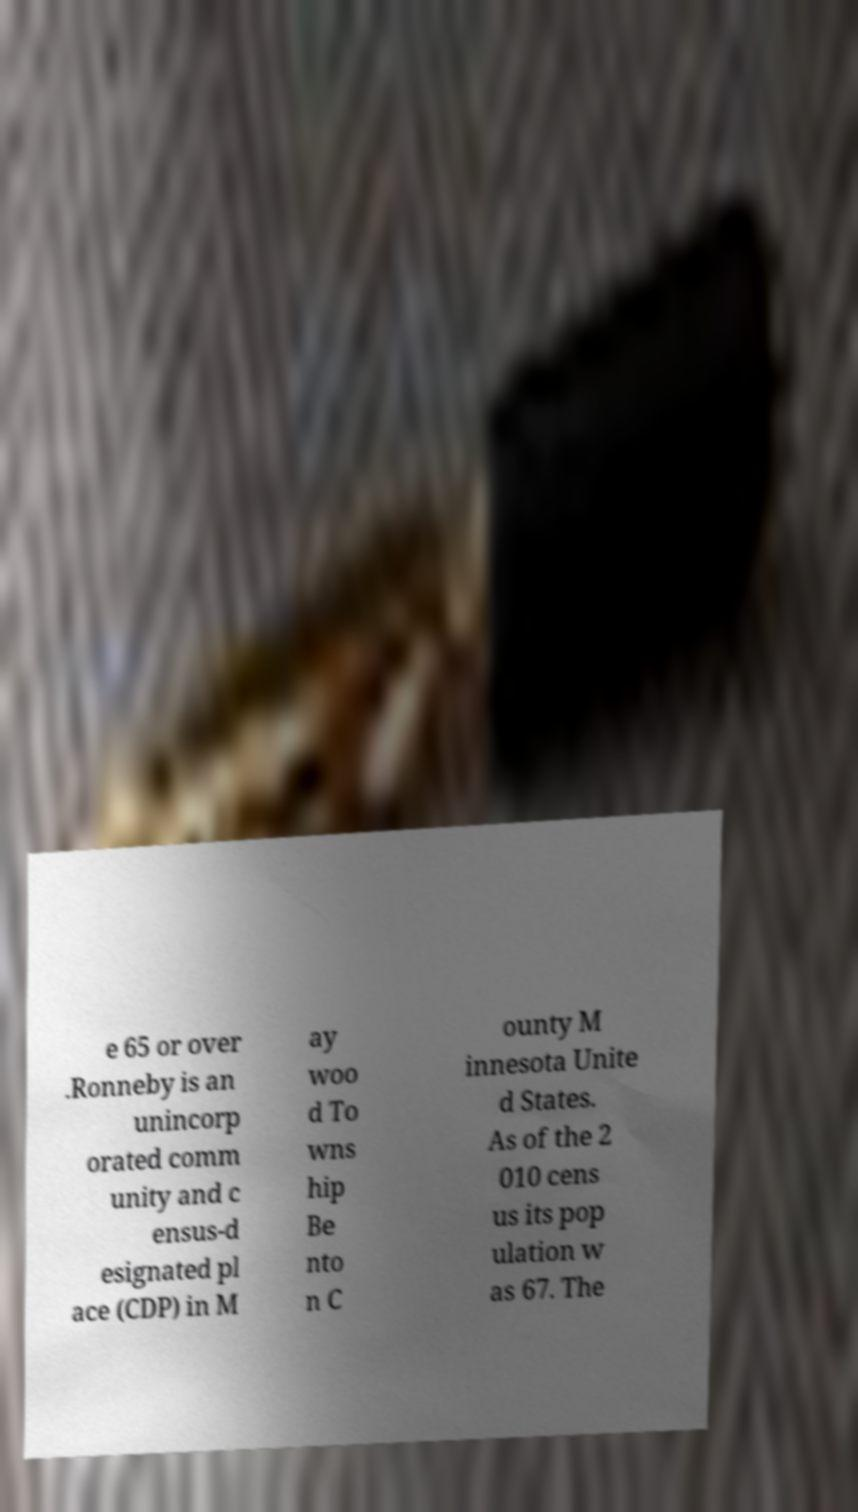Could you extract and type out the text from this image? e 65 or over .Ronneby is an unincorp orated comm unity and c ensus-d esignated pl ace (CDP) in M ay woo d To wns hip Be nto n C ounty M innesota Unite d States. As of the 2 010 cens us its pop ulation w as 67. The 